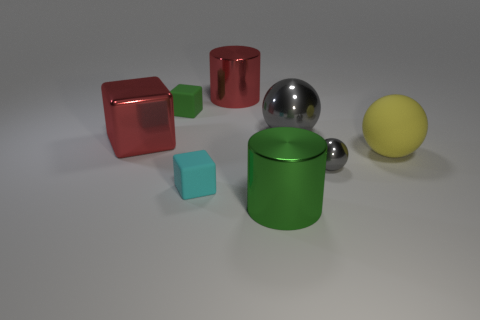What number of cubes are both in front of the green block and to the left of the small cyan matte object?
Your answer should be compact. 1. What is the shape of the big shiny object in front of the small cyan matte cube?
Keep it short and to the point. Cylinder. How many large red cubes are made of the same material as the green cylinder?
Provide a short and direct response. 1. There is a large gray shiny thing; is it the same shape as the red object that is behind the large gray ball?
Make the answer very short. No. There is a shiny cylinder behind the large shiny cylinder in front of the big gray metallic thing; is there a red object that is left of it?
Your answer should be compact. Yes. What size is the gray sphere in front of the large gray sphere?
Give a very brief answer. Small. What is the material of the green block that is the same size as the cyan rubber thing?
Make the answer very short. Rubber. Does the large rubber object have the same shape as the tiny gray object?
Your answer should be compact. Yes. How many objects are either large rubber spheres or rubber objects on the left side of the yellow object?
Provide a short and direct response. 3. What is the material of the big object that is the same color as the big cube?
Provide a succinct answer. Metal. 